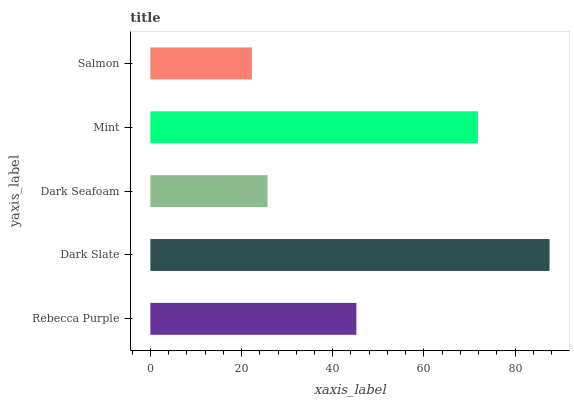Is Salmon the minimum?
Answer yes or no. Yes. Is Dark Slate the maximum?
Answer yes or no. Yes. Is Dark Seafoam the minimum?
Answer yes or no. No. Is Dark Seafoam the maximum?
Answer yes or no. No. Is Dark Slate greater than Dark Seafoam?
Answer yes or no. Yes. Is Dark Seafoam less than Dark Slate?
Answer yes or no. Yes. Is Dark Seafoam greater than Dark Slate?
Answer yes or no. No. Is Dark Slate less than Dark Seafoam?
Answer yes or no. No. Is Rebecca Purple the high median?
Answer yes or no. Yes. Is Rebecca Purple the low median?
Answer yes or no. Yes. Is Salmon the high median?
Answer yes or no. No. Is Salmon the low median?
Answer yes or no. No. 